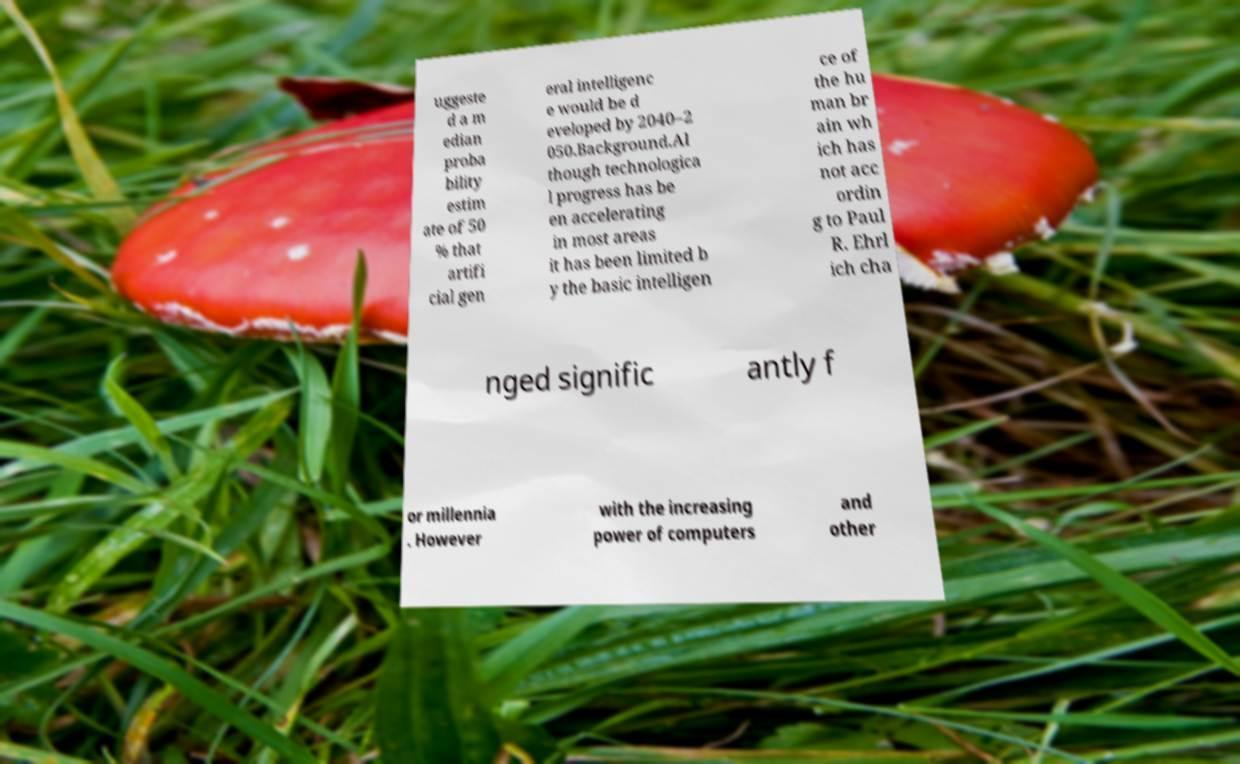Could you assist in decoding the text presented in this image and type it out clearly? uggeste d a m edian proba bility estim ate of 50 % that artifi cial gen eral intelligenc e would be d eveloped by 2040–2 050.Background.Al though technologica l progress has be en accelerating in most areas it has been limited b y the basic intelligen ce of the hu man br ain wh ich has not acc ordin g to Paul R. Ehrl ich cha nged signific antly f or millennia . However with the increasing power of computers and other 